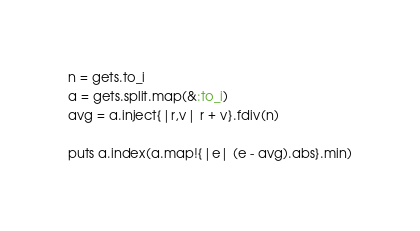<code> <loc_0><loc_0><loc_500><loc_500><_Ruby_>n = gets.to_i
a = gets.split.map(&:to_i)
avg = a.inject{|r,v| r + v}.fdiv(n)

puts a.index(a.map!{|e| (e - avg).abs}.min)</code> 